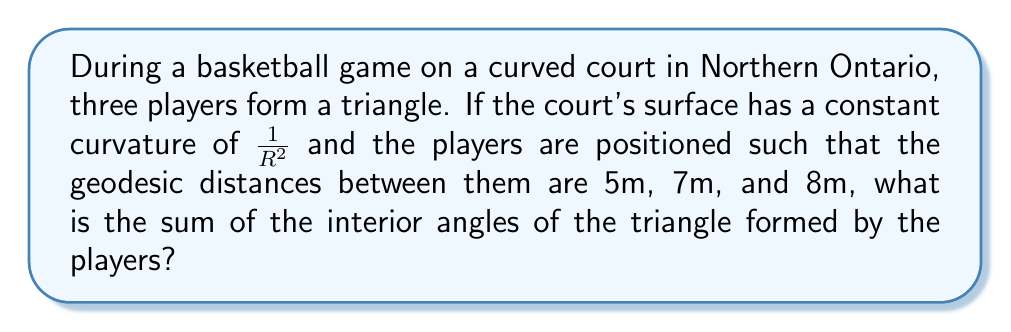Help me with this question. Let's approach this step-by-step:

1) In non-Euclidean geometry, specifically on a curved surface, the sum of the angles in a triangle is not necessarily 180°. The difference from 180° is called the angular excess.

2) The Gauss-Bonnet theorem relates the angular excess to the area of the triangle and the curvature of the surface. For a triangle on a surface with constant curvature $K$, the theorem states:

   $$A + \alpha + \beta + \gamma = 2\pi + KA$$

   where $A$ is the area of the triangle, $\alpha$, $\beta$, and $\gamma$ are the angles of the triangle, and $K$ is the Gaussian curvature.

3) We're given that the curvature is $K = \frac{1}{R^2}$.

4) To find the area, we can use the spherical excess formula:

   $$A = R^2E$$

   where $E$ is the spherical excess in radians.

5) The spherical excess $E$ can be calculated using the side lengths $a$, $b$, and $c$ of the triangle:

   $$E = 4 \arctan \sqrt{\tan(\frac{s}{2}) \tan(\frac{s-a}{2}) \tan(\frac{s-b}{2}) \tan(\frac{s-c}{2})}$$

   where $s = \frac{a+b+c}{2}$ is the semi-perimeter.

6) Calculating $s$:
   $$s = \frac{5+7+8}{2} = 10$$

7) Substituting into the spherical excess formula:

   $$E = 4 \arctan \sqrt{\tan(5) \tan(2.5) \tan(1.5) \tan(1)}$$

8) This gives us $E \approx 0.0361$ radians.

9) Now we can calculate the area:
   $$A = R^2 \cdot 0.0361 = 0.0361R^2$$

10) Substituting this into the Gauss-Bonnet theorem:

    $$0.0361R^2 + \alpha + \beta + \gamma = 2\pi + \frac{0.0361R^2}{R^2}$$

11) Simplifying:

    $$\alpha + \beta + \gamma = 2\pi + 0.0361 - 0.0361 = 2\pi$$

12) Converting to degrees:

    $$\alpha + \beta + \gamma = 360°$$

Therefore, the sum of the interior angles of the triangle is 360°.
Answer: 360° 